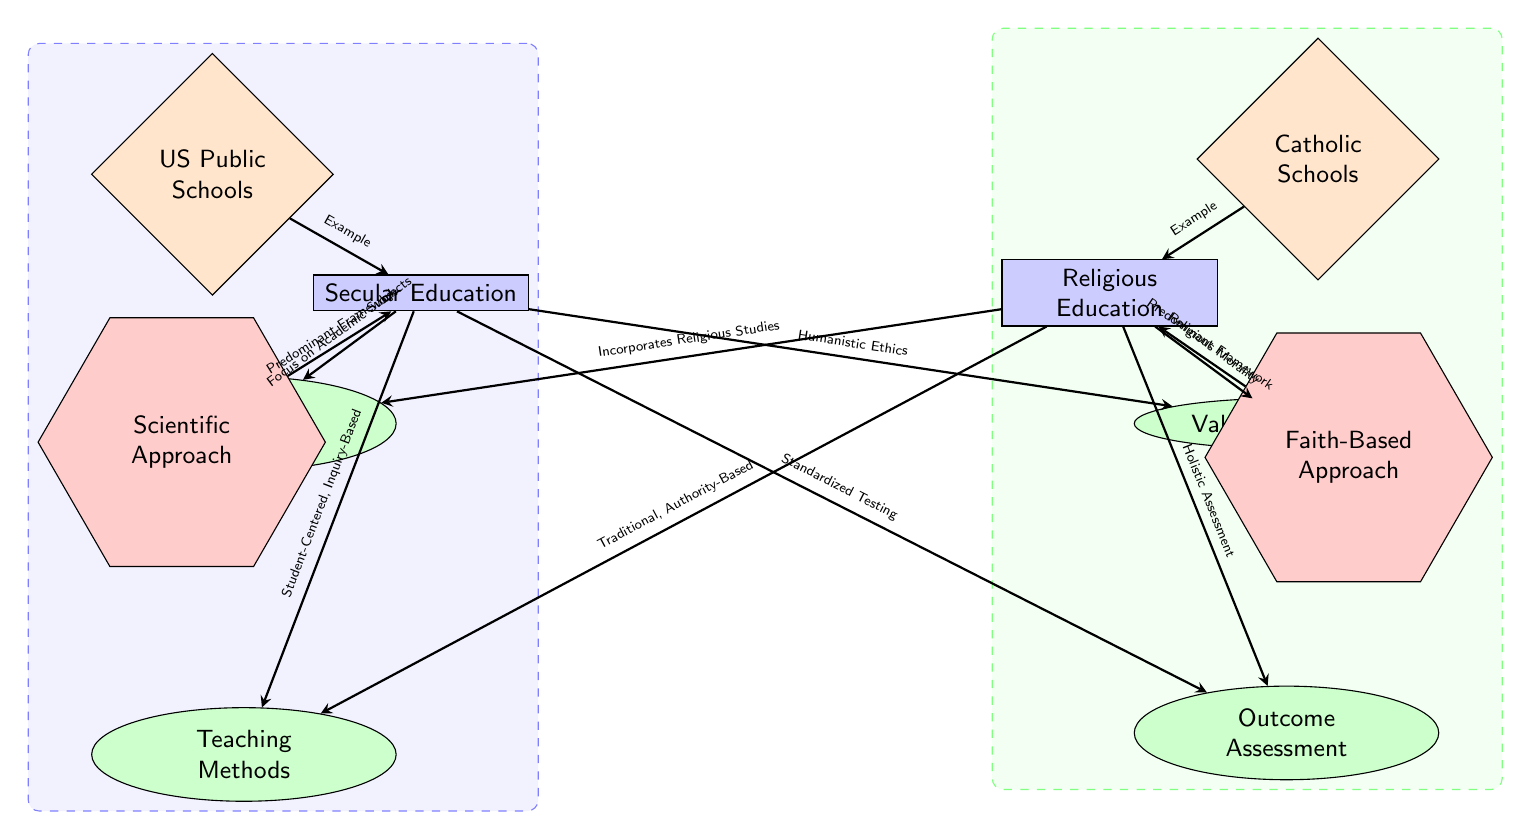What are the two main types of education systems depicted? The diagram clearly lists two main types of education systems: “Secular Education” and “Religious Education,” which are represented at the top of the diagram.
Answer: Secular Education, Religious Education Which teaching method is associated with secular education? According to the arrows indicating relationships in the diagram, the teaching method linked with secular education is "Student-Centered, Inquiry-Based." This is labeled directly below the secular education node.
Answer: Student-Centered, Inquiry-Based How many aspects are there under each education system? The diagram indicates that there are four aspects listed under each education type. These aspects are curriculum content, teaching methods, values and ethics, and outcome assessment.
Answer: 4 What type of approach is predominant in religious education? The diagram points out that the "Faith-Based Approach" is the predominant framework for religious education, as indicated by the flow from the religious education node.
Answer: Faith-Based Approach In terms of curriculum content, what distinguishes religious education from secular education? The diagram specifies that while secular education focuses on "Academic Subjects," religious education incorporates "Religious Studies." This shows a clear distinction shown in their respective arrows leading from each education type to curriculum content.
Answer: Incorporates Religious Studies How does the outcome assessment in secular education differ from that in religious education? The diagram outlines that secular education uses "Standardized Testing" for outcome assessment, whereas religious education employs "Holistic Assessment." The separation of these assessment types creates a clear contrast between the two systems’ approaches.
Answer: Standardized Testing, Holistic Assessment Which educational example is provided for secular education? The diagram names “US Public Schools” as a specific example under the secular education system, indicated by a connecting arrow from the example node to the secular education node.
Answer: US Public Schools What is the relationship between values and ethics in secular education as per the diagram? The arrow from the secular education node to values indicates that the relationship is characterized by "Humanistic Ethics." This provides a foundational understanding of the ethical framework within the secular education system.
Answer: Humanistic Ethics 